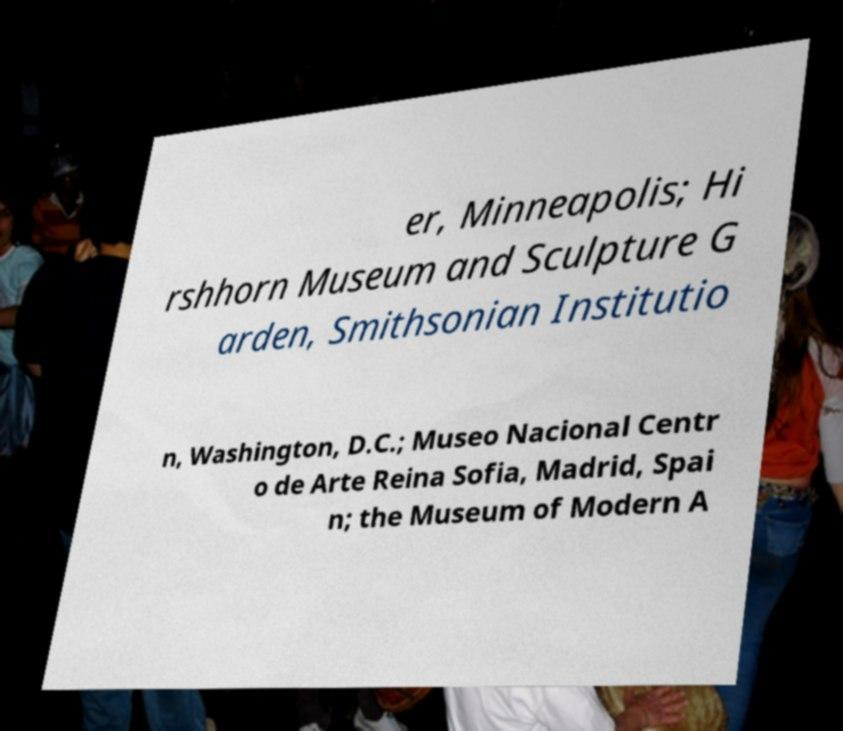Can you read and provide the text displayed in the image?This photo seems to have some interesting text. Can you extract and type it out for me? er, Minneapolis; Hi rshhorn Museum and Sculpture G arden, Smithsonian Institutio n, Washington, D.C.; Museo Nacional Centr o de Arte Reina Sofia, Madrid, Spai n; the Museum of Modern A 